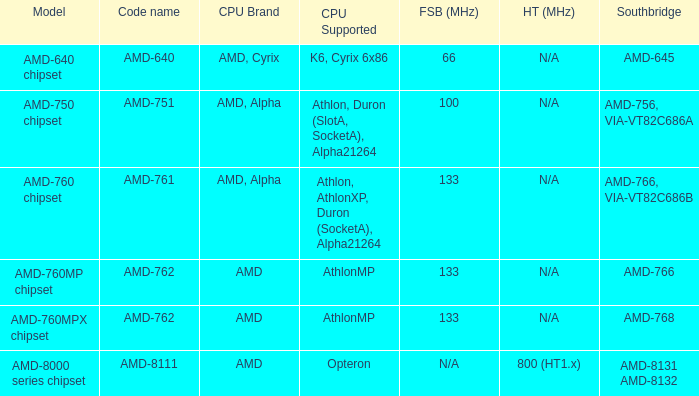What is the code name when the Southbridge shows as amd-766, via-vt82c686b? AMD-761. Can you give me this table as a dict? {'header': ['Model', 'Code name', 'CPU Brand', 'CPU Supported', 'FSB (MHz)', 'HT (MHz)', 'Southbridge'], 'rows': [['AMD-640 chipset', 'AMD-640', 'AMD, Cyrix', 'K6, Cyrix 6x86', '66', 'N/A', 'AMD-645'], ['AMD-750 chipset', 'AMD-751', 'AMD, Alpha', 'Athlon, Duron (SlotA, SocketA), Alpha21264', '100', 'N/A', 'AMD-756, VIA-VT82C686A'], ['AMD-760 chipset', 'AMD-761', 'AMD, Alpha', 'Athlon, AthlonXP, Duron (SocketA), Alpha21264', '133', 'N/A', 'AMD-766, VIA-VT82C686B'], ['AMD-760MP chipset', 'AMD-762', 'AMD', 'AthlonMP', '133', 'N/A', 'AMD-766'], ['AMD-760MPX chipset', 'AMD-762', 'AMD', 'AthlonMP', '133', 'N/A', 'AMD-768'], ['AMD-8000 series chipset', 'AMD-8111', 'AMD', 'Opteron', 'N/A', '800 (HT1.x)', 'AMD-8131 AMD-8132']]} 